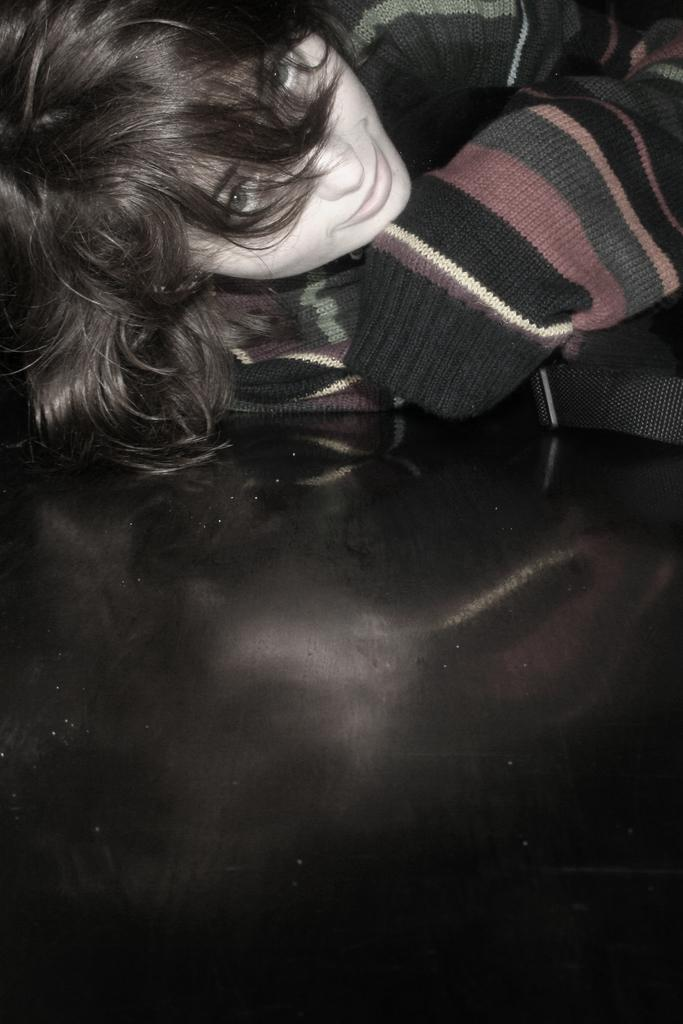Who is present in the image? There is a girl in the image. What is the girl wearing? The girl is wearing a sweater. What is the color or material of the surface in the image? The surface in the image is black. How many rabbits can be seen in the image? There are no rabbits present in the image. What type of hook is the girl holding in the image? There is no hook present in the image. 